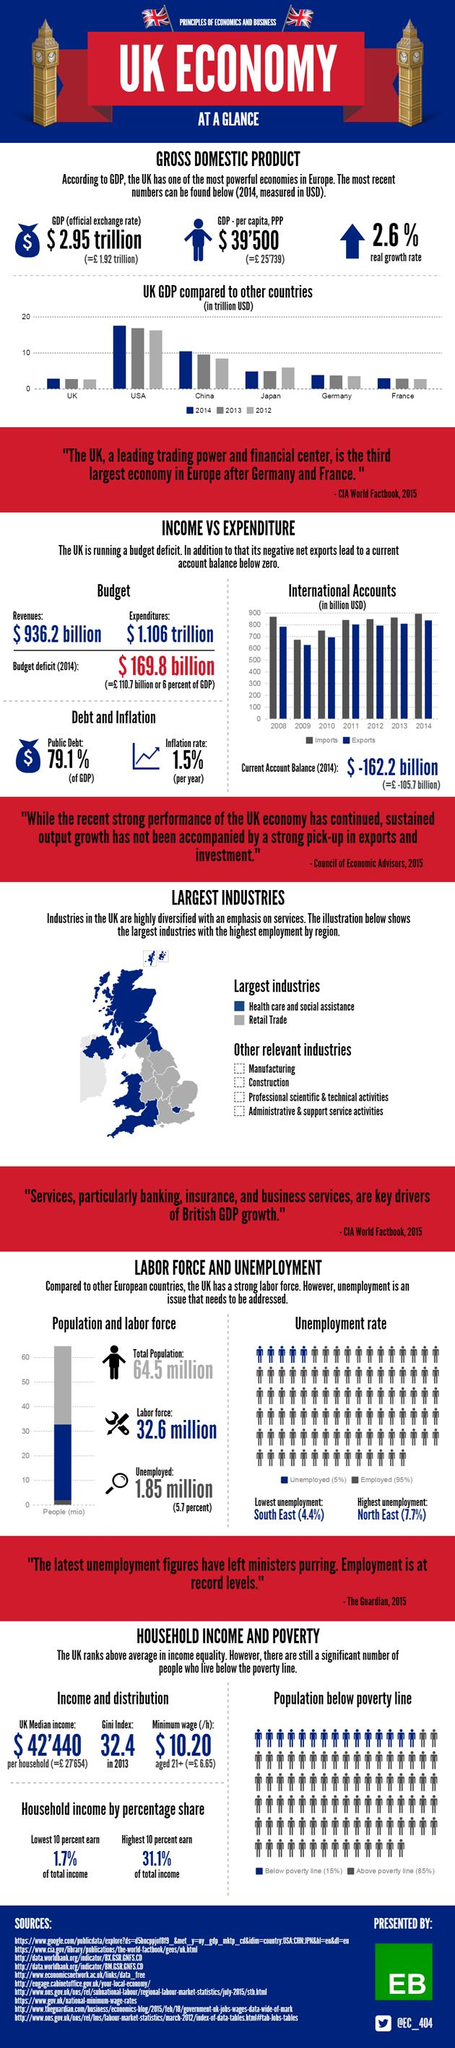List a handful of essential elements in this visual. China ranks second in terms of GDP among all countries. The budget deficit of the United Kingdom for the year 2014 was 110.7 billion pounds. The North East region of the United Kingdom has the highest unemployment rate among all regions in the country. In the context of representing the category 'health care and social assistance,' blue is the color typically used. In the year 2009, the United Kingdom had the lowest imports and exports in its history. 